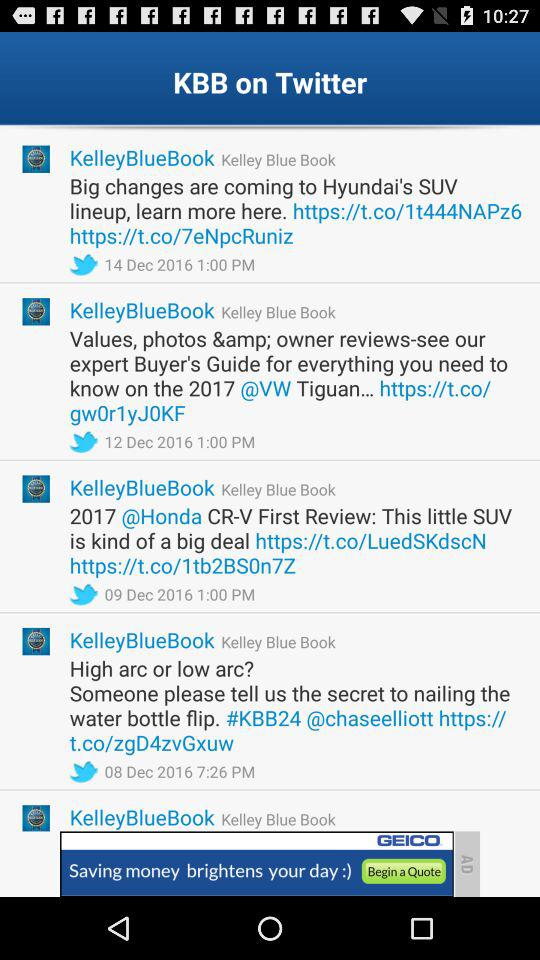What is the amount of the dealer's invoice for the "2017 Acura ILX"? The amount is $27,299. 